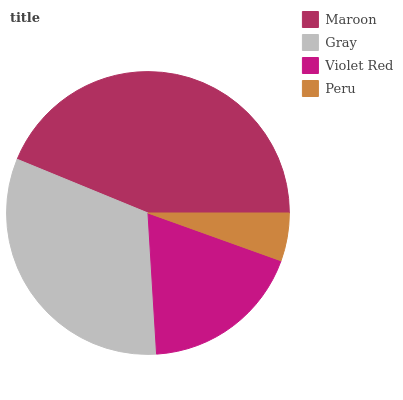Is Peru the minimum?
Answer yes or no. Yes. Is Maroon the maximum?
Answer yes or no. Yes. Is Gray the minimum?
Answer yes or no. No. Is Gray the maximum?
Answer yes or no. No. Is Maroon greater than Gray?
Answer yes or no. Yes. Is Gray less than Maroon?
Answer yes or no. Yes. Is Gray greater than Maroon?
Answer yes or no. No. Is Maroon less than Gray?
Answer yes or no. No. Is Gray the high median?
Answer yes or no. Yes. Is Violet Red the low median?
Answer yes or no. Yes. Is Maroon the high median?
Answer yes or no. No. Is Peru the low median?
Answer yes or no. No. 